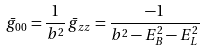<formula> <loc_0><loc_0><loc_500><loc_500>\bar { g } _ { 0 0 } = \frac { 1 } { b ^ { 2 } } \, \bar { g } _ { z z } = \frac { - 1 } { b ^ { 2 } - E _ { B } ^ { 2 } - E _ { L } ^ { 2 } }</formula> 